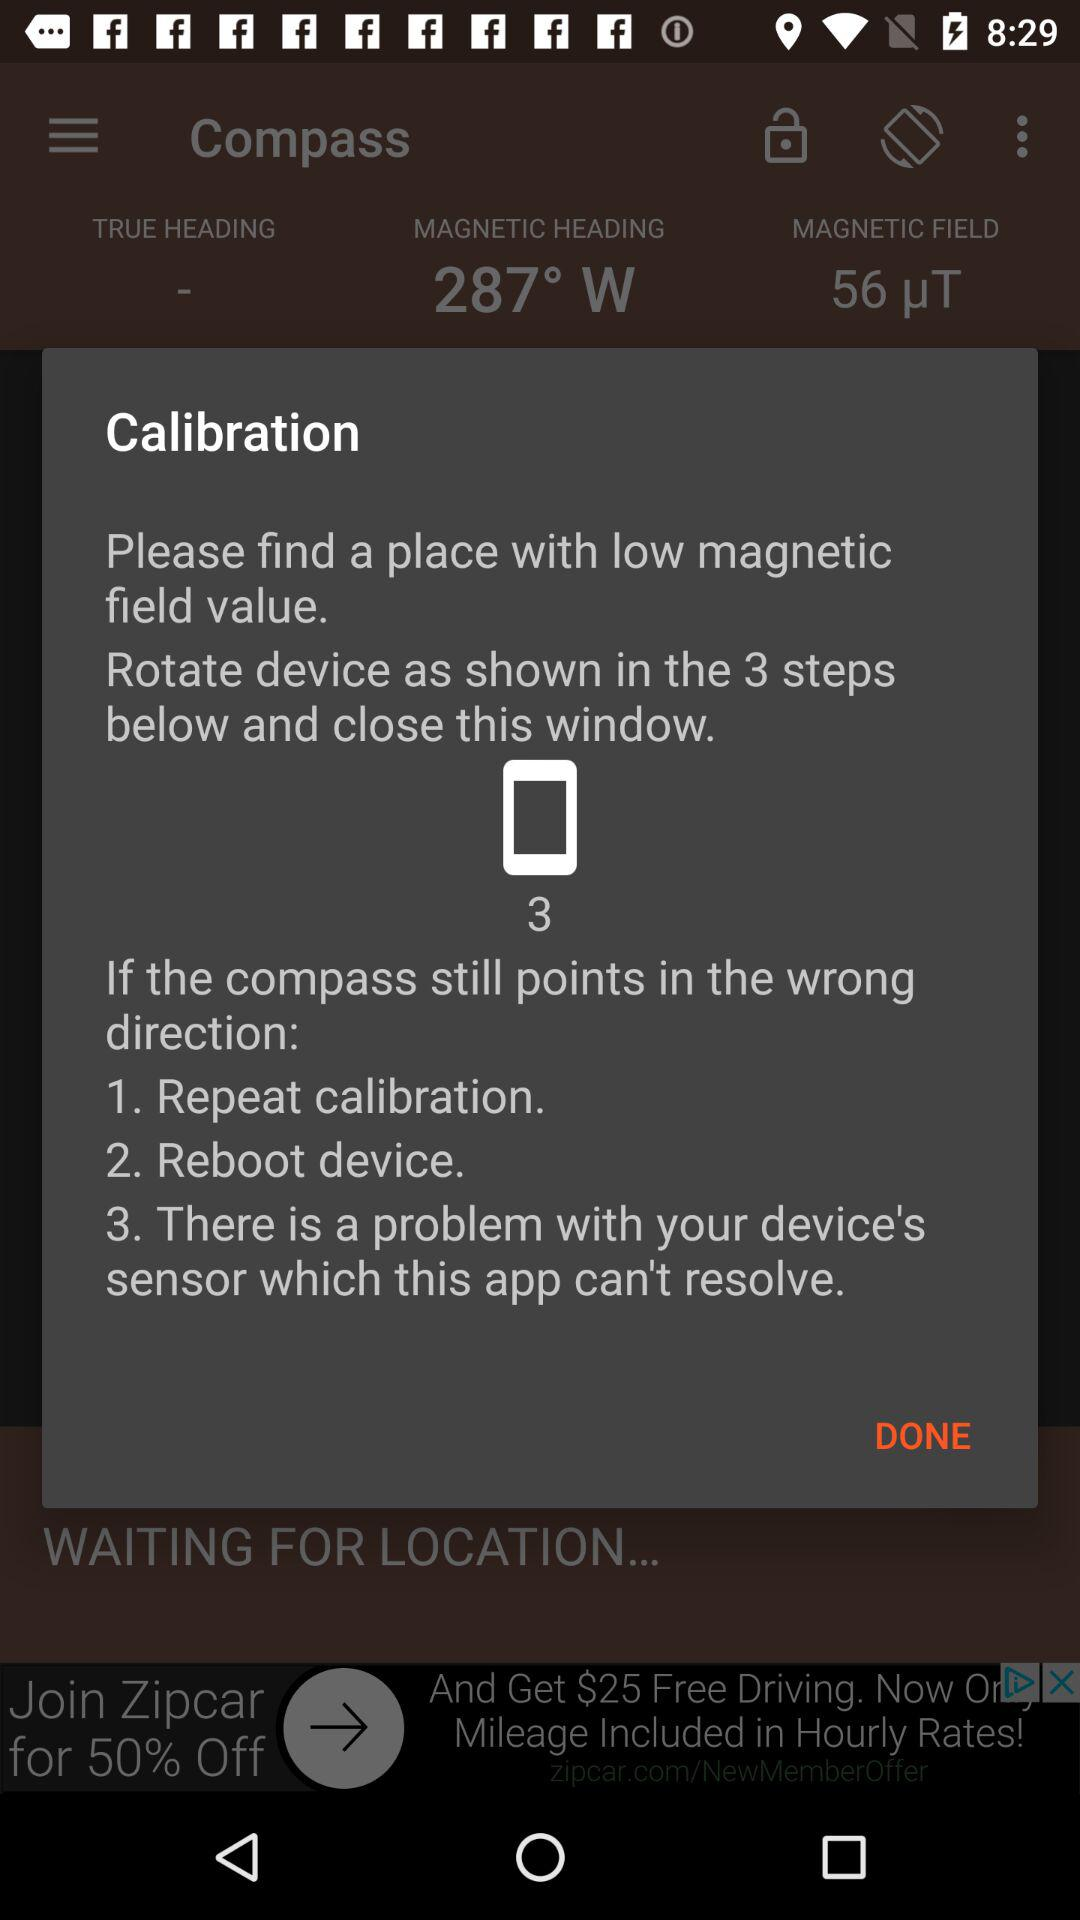How many options are there for fixing a compass that points in the wrong direction?
Answer the question using a single word or phrase. 3 